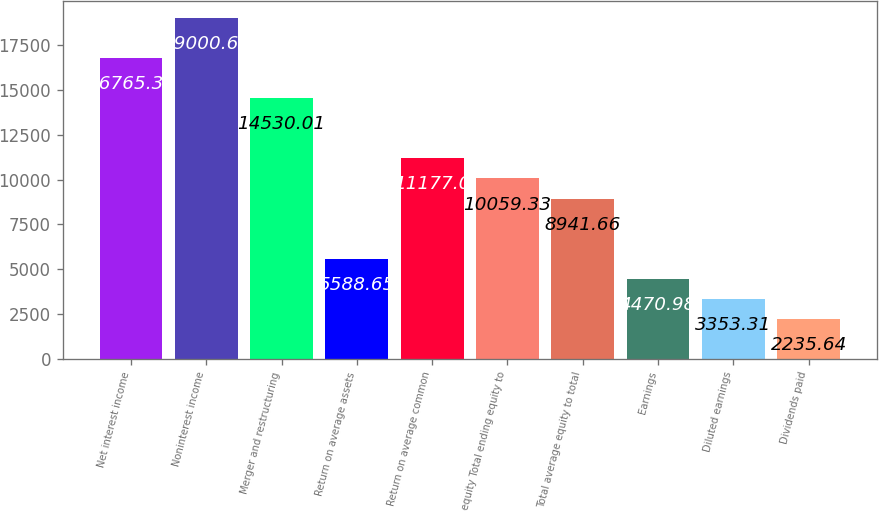Convert chart to OTSL. <chart><loc_0><loc_0><loc_500><loc_500><bar_chart><fcel>Net interest income<fcel>Noninterest income<fcel>Merger and restructuring<fcel>Return on average assets<fcel>Return on average common<fcel>equity Total ending equity to<fcel>Total average equity to total<fcel>Earnings<fcel>Diluted earnings<fcel>Dividends paid<nl><fcel>16765.3<fcel>19000.7<fcel>14530<fcel>5588.65<fcel>11177<fcel>10059.3<fcel>8941.66<fcel>4470.98<fcel>3353.31<fcel>2235.64<nl></chart> 